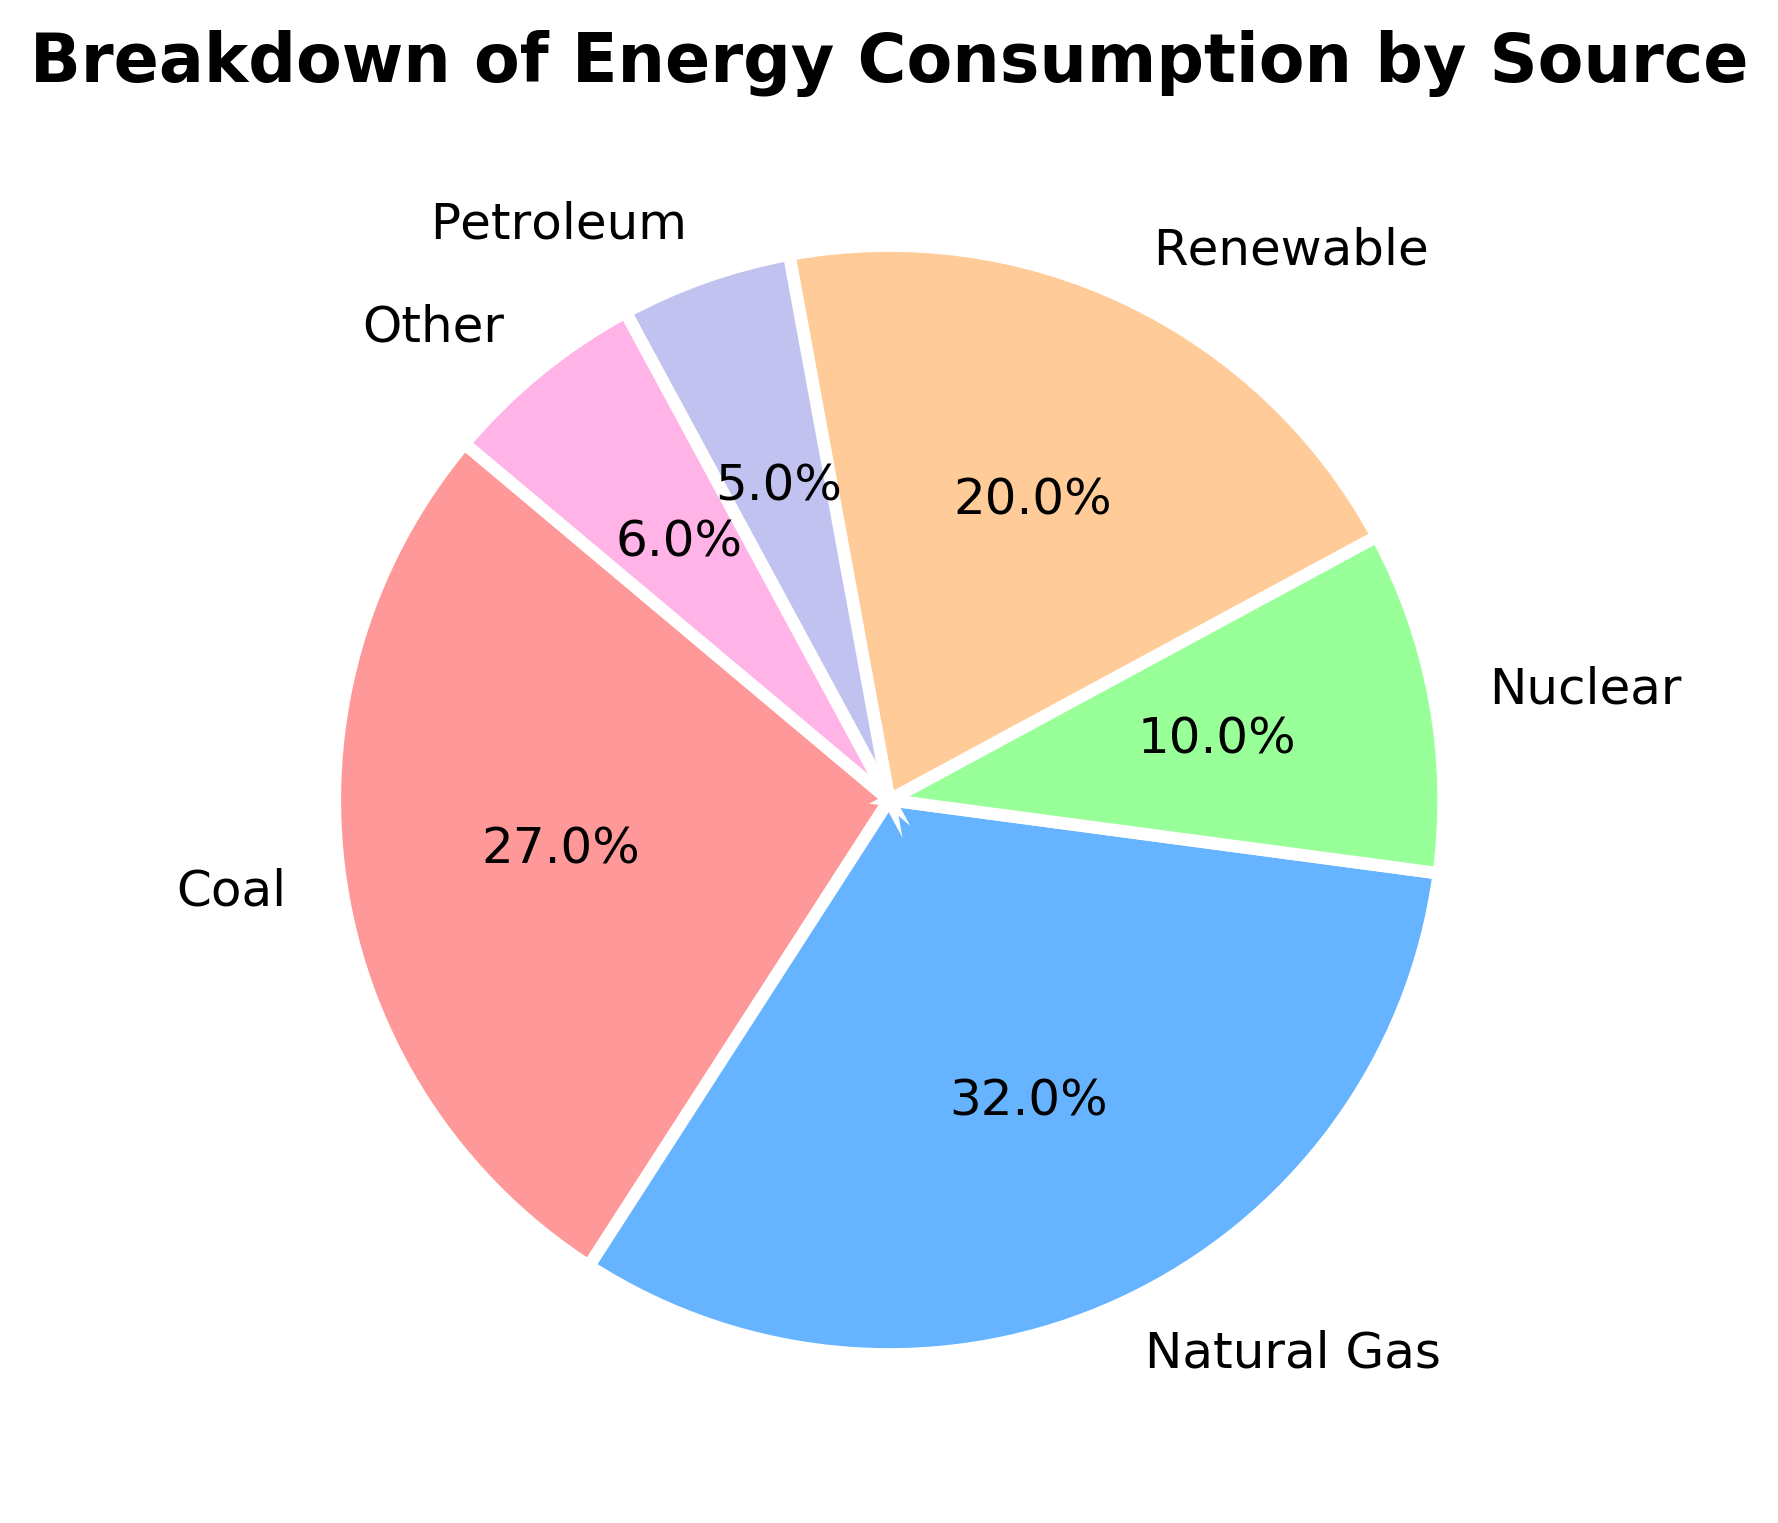Which energy source has the highest percentage of consumption? The energy source with the highest percentage of consumption can be identified by looking for the largest slice in the pie chart. The biggest slice corresponds to Natural Gas.
Answer: Natural Gas What is the combined percentage of Coal and Renewable energy sources? To find the combined percentage, add the percentages of Coal (27.0%) and Renewable (20.0%). The sum is 27.0 + 20.0 = 47.0.
Answer: 47.0% Which sources have smaller consumption rates than Nuclear? Nuclear has a consumption rate of 10.0%. By comparing the slices, we can see that Petroleum (5.0%) and Other (6.0%) are both smaller than Nuclear.
Answer: Petroleum, Other How much larger is Natural Gas consumption compared to Coal? To find the difference, subtract the percentage of Coal (27.0%) from the percentage of Natural Gas (32.0%). The difference is 32.0 - 27.0 = 5.0.
Answer: 5.0% If Renewable energy consumption increased by 10%, what would its new percentage be and how would it compare to Natural Gas? First, find the new percentage of Renewable by adding 10% to its current 20.0%, resulting in 30.0%. Then compare this to Natural Gas, which is 32.0%. Renewable would still be slightly less than Natural Gas by 2.0%.
Answer: 30.0%, slightly less What are the colors representing the Renewable and Petroleum energy sources? By examining the pie chart, Renewable is represented by a green slice and Petroleum is represented by a yellowish slice.
Answer: green, yellowish Which sources together make up exactly half of the energy consumption? To find a combination that makes up 50%, check pairs of sources. Coal (27.0%) and Renewable (20.0%) combined make up 47.0%, not exactly half. However, Natural Gas (32.0%) and Renewable (20.0%) cover 52.0%, so no exact half found except when using parts of slices which isn't practical in this case.
Answer: None What is the percentage of all non-renewable sources combined? Sum the percentages of Coal (27.0%), Natural Gas (32.0%), Nuclear (10.0%), Petroleum (5.0%), and Other (6.0%) to get the total. The sum is 27.0 + 32.0 + 10.0 + 5.0 + 6.0 = 80.0%.
Answer: 80.0% How does the consumption percentage of Renewable compare to Nuclear? Compare the slices for Renewable (20.0%) and Nuclear (10.0%). Renewable's percentage is double that of Nuclear.
Answer: Renewable is double 